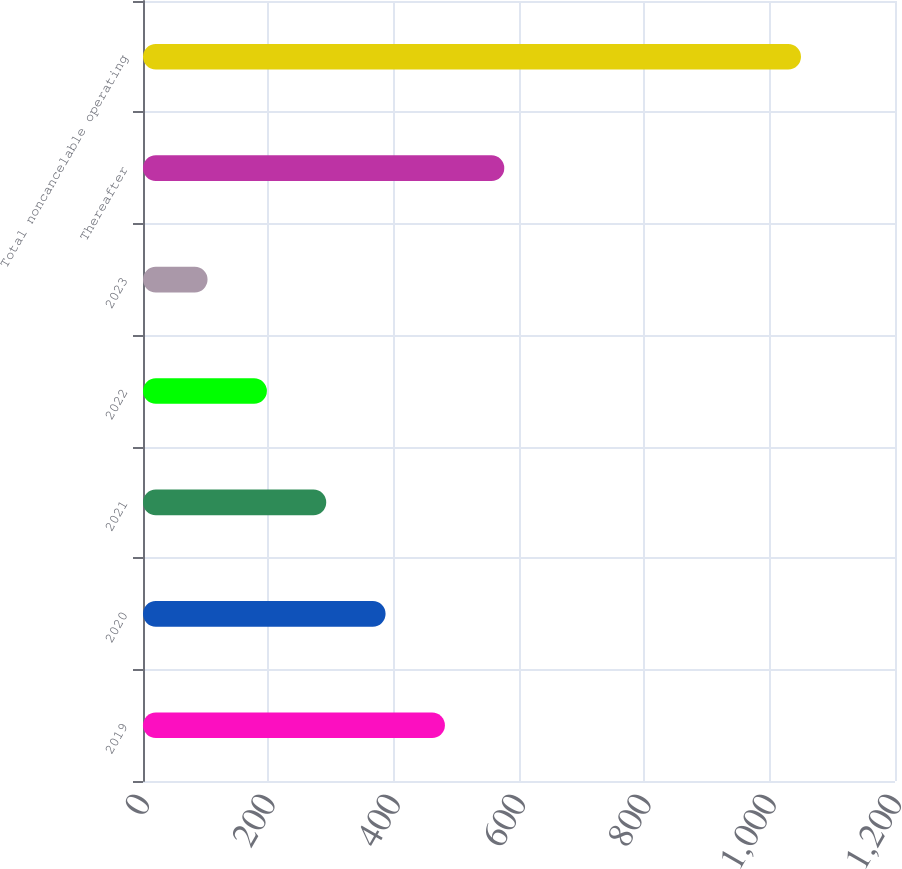<chart> <loc_0><loc_0><loc_500><loc_500><bar_chart><fcel>2019<fcel>2020<fcel>2021<fcel>2022<fcel>2023<fcel>Thereafter<fcel>Total noncancelable operating<nl><fcel>481.8<fcel>387.1<fcel>292.4<fcel>197.7<fcel>103<fcel>576.5<fcel>1050<nl></chart> 